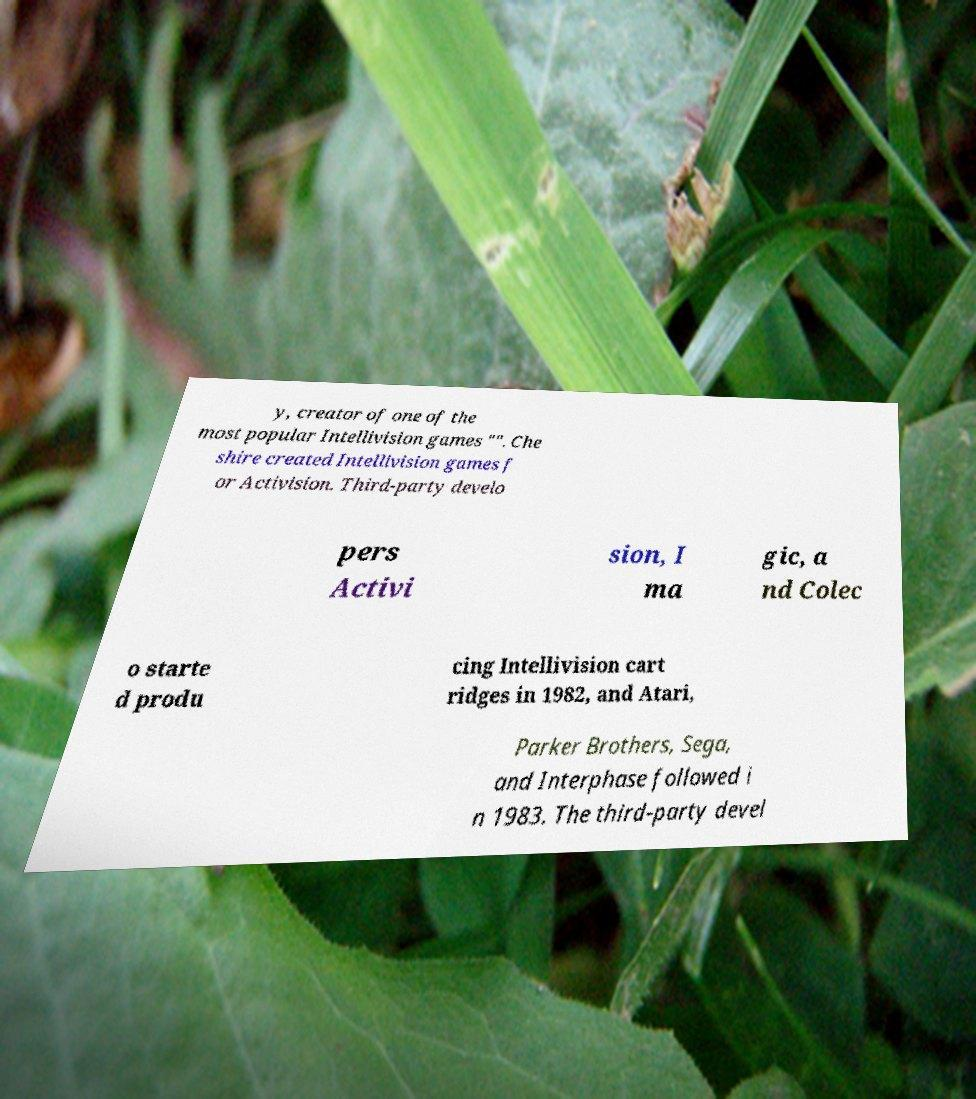Can you accurately transcribe the text from the provided image for me? y, creator of one of the most popular Intellivision games "". Che shire created Intellivision games f or Activision. Third-party develo pers Activi sion, I ma gic, a nd Colec o starte d produ cing Intellivision cart ridges in 1982, and Atari, Parker Brothers, Sega, and Interphase followed i n 1983. The third-party devel 